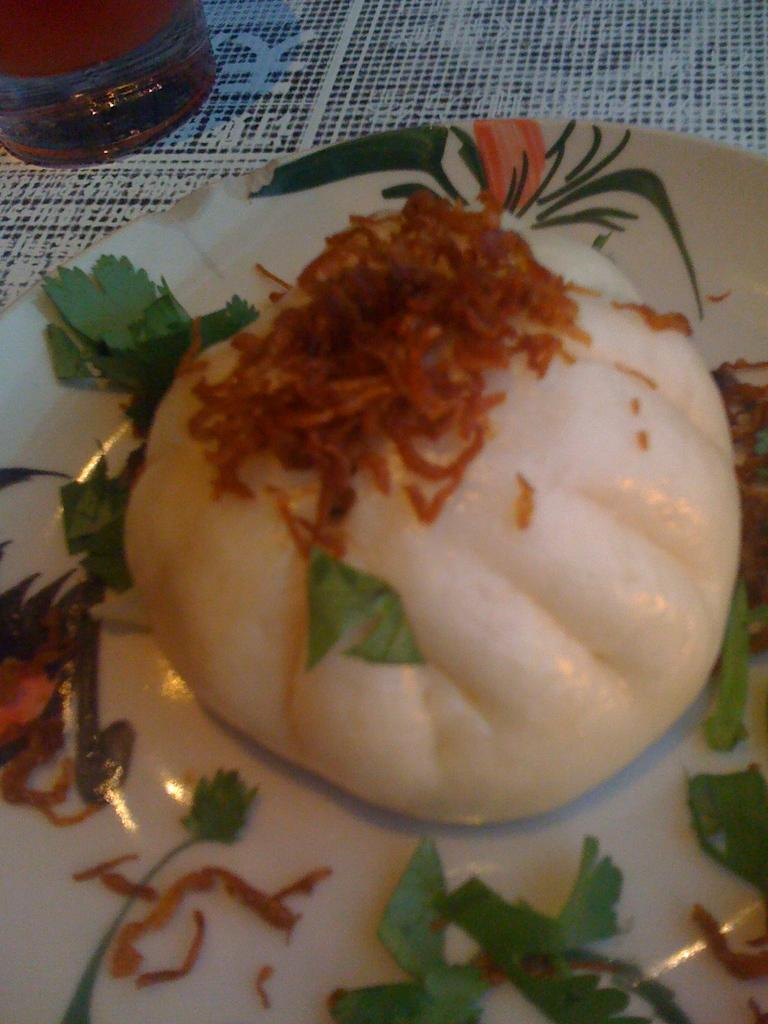What is on the plate that is visible in the image? There is food on a plate in the image. What else can be seen on the table in the image? There is a glass on the table in the image. What type of ball is being used to make a request in the image? There is no ball or request present in the image. How many lines can be seen on the plate in the image? There are no lines visible on the plate in the image; it contains food. 